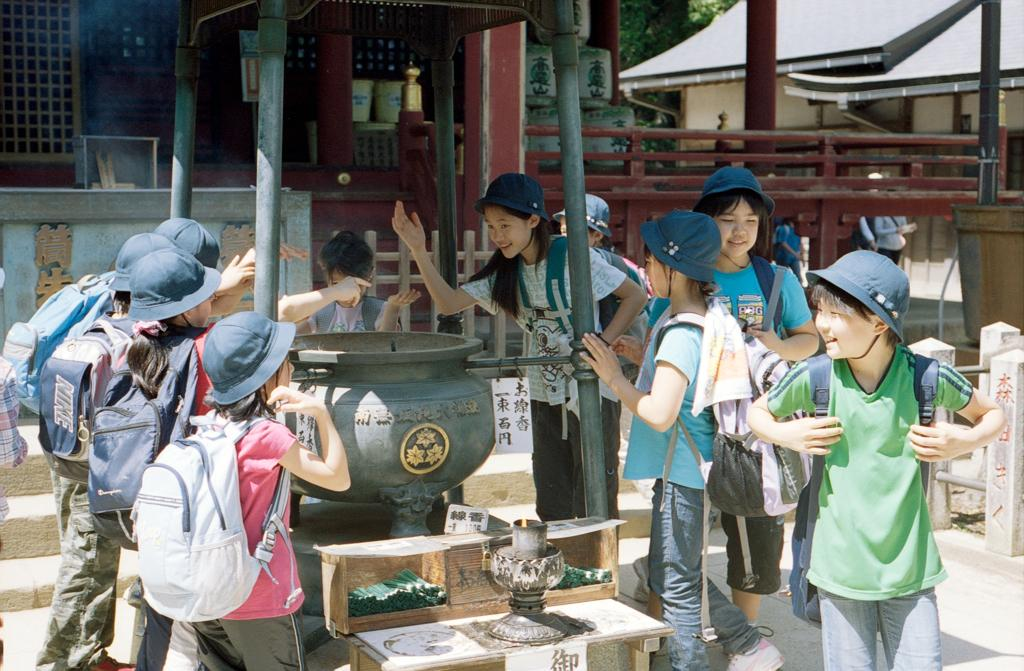Who is present in the image? There are kids in the image. What are the kids wearing? The kids are wearing bags. What expression do the kids have? The kids are smiling. What can be seen in the background of the image? There are houses around the kids. What type of account is the kid opening in the image? There is no indication in the image that the kids are opening any accounts, as they are wearing bags and smiling. 